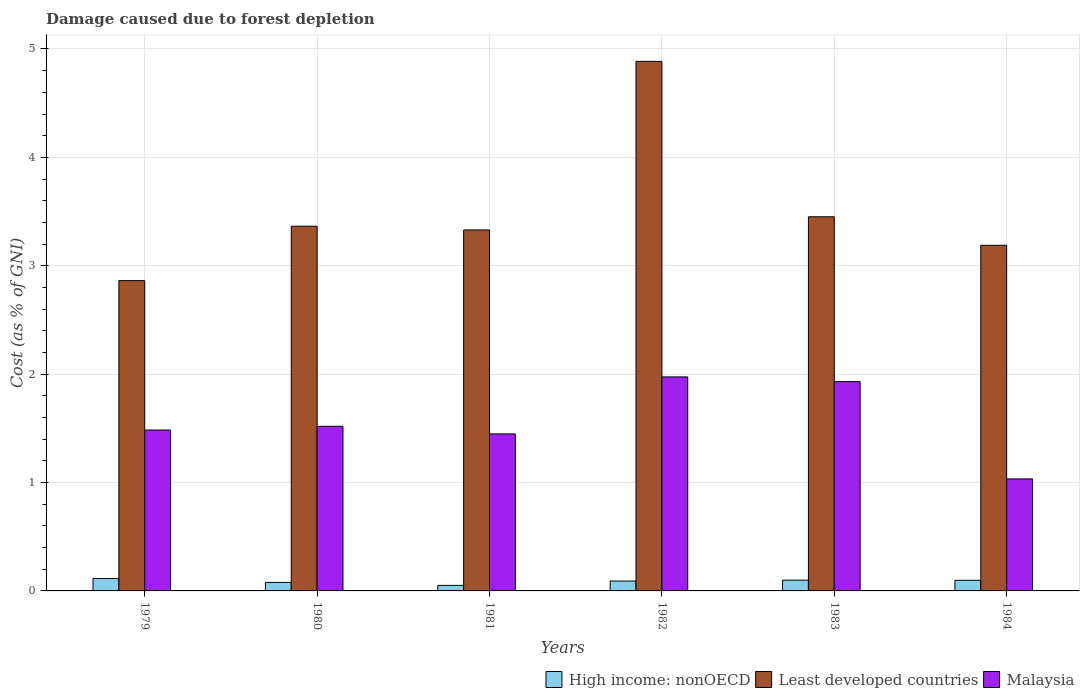How many different coloured bars are there?
Provide a short and direct response. 3. How many groups of bars are there?
Your response must be concise. 6. Are the number of bars on each tick of the X-axis equal?
Your answer should be very brief. Yes. What is the label of the 3rd group of bars from the left?
Offer a very short reply. 1981. What is the cost of damage caused due to forest depletion in Malaysia in 1982?
Keep it short and to the point. 1.97. Across all years, what is the maximum cost of damage caused due to forest depletion in Least developed countries?
Ensure brevity in your answer.  4.89. Across all years, what is the minimum cost of damage caused due to forest depletion in High income: nonOECD?
Provide a succinct answer. 0.05. In which year was the cost of damage caused due to forest depletion in High income: nonOECD maximum?
Your answer should be compact. 1979. In which year was the cost of damage caused due to forest depletion in Malaysia minimum?
Provide a succinct answer. 1984. What is the total cost of damage caused due to forest depletion in High income: nonOECD in the graph?
Your response must be concise. 0.53. What is the difference between the cost of damage caused due to forest depletion in High income: nonOECD in 1979 and that in 1980?
Ensure brevity in your answer.  0.04. What is the difference between the cost of damage caused due to forest depletion in High income: nonOECD in 1982 and the cost of damage caused due to forest depletion in Malaysia in 1979?
Make the answer very short. -1.39. What is the average cost of damage caused due to forest depletion in High income: nonOECD per year?
Your response must be concise. 0.09. In the year 1983, what is the difference between the cost of damage caused due to forest depletion in High income: nonOECD and cost of damage caused due to forest depletion in Least developed countries?
Your answer should be compact. -3.35. What is the ratio of the cost of damage caused due to forest depletion in High income: nonOECD in 1981 to that in 1983?
Give a very brief answer. 0.51. Is the cost of damage caused due to forest depletion in Malaysia in 1979 less than that in 1984?
Your answer should be compact. No. What is the difference between the highest and the second highest cost of damage caused due to forest depletion in High income: nonOECD?
Ensure brevity in your answer.  0.02. What is the difference between the highest and the lowest cost of damage caused due to forest depletion in High income: nonOECD?
Your response must be concise. 0.06. Is the sum of the cost of damage caused due to forest depletion in Least developed countries in 1979 and 1982 greater than the maximum cost of damage caused due to forest depletion in Malaysia across all years?
Your response must be concise. Yes. What does the 3rd bar from the left in 1984 represents?
Offer a very short reply. Malaysia. What does the 1st bar from the right in 1984 represents?
Provide a short and direct response. Malaysia. How many bars are there?
Offer a terse response. 18. How many years are there in the graph?
Provide a short and direct response. 6. Does the graph contain any zero values?
Ensure brevity in your answer.  No. Does the graph contain grids?
Offer a very short reply. Yes. How many legend labels are there?
Provide a short and direct response. 3. How are the legend labels stacked?
Your response must be concise. Horizontal. What is the title of the graph?
Your answer should be compact. Damage caused due to forest depletion. Does "Central Europe" appear as one of the legend labels in the graph?
Provide a short and direct response. No. What is the label or title of the X-axis?
Your answer should be compact. Years. What is the label or title of the Y-axis?
Provide a succinct answer. Cost (as % of GNI). What is the Cost (as % of GNI) of High income: nonOECD in 1979?
Offer a very short reply. 0.11. What is the Cost (as % of GNI) in Least developed countries in 1979?
Provide a succinct answer. 2.86. What is the Cost (as % of GNI) of Malaysia in 1979?
Offer a very short reply. 1.48. What is the Cost (as % of GNI) in High income: nonOECD in 1980?
Give a very brief answer. 0.08. What is the Cost (as % of GNI) in Least developed countries in 1980?
Offer a very short reply. 3.36. What is the Cost (as % of GNI) of Malaysia in 1980?
Provide a short and direct response. 1.52. What is the Cost (as % of GNI) of High income: nonOECD in 1981?
Your answer should be compact. 0.05. What is the Cost (as % of GNI) of Least developed countries in 1981?
Keep it short and to the point. 3.33. What is the Cost (as % of GNI) in Malaysia in 1981?
Provide a short and direct response. 1.45. What is the Cost (as % of GNI) in High income: nonOECD in 1982?
Your answer should be compact. 0.09. What is the Cost (as % of GNI) in Least developed countries in 1982?
Offer a terse response. 4.89. What is the Cost (as % of GNI) of Malaysia in 1982?
Keep it short and to the point. 1.97. What is the Cost (as % of GNI) in High income: nonOECD in 1983?
Your answer should be very brief. 0.1. What is the Cost (as % of GNI) of Least developed countries in 1983?
Offer a terse response. 3.45. What is the Cost (as % of GNI) in Malaysia in 1983?
Keep it short and to the point. 1.93. What is the Cost (as % of GNI) in High income: nonOECD in 1984?
Provide a short and direct response. 0.1. What is the Cost (as % of GNI) in Least developed countries in 1984?
Ensure brevity in your answer.  3.19. What is the Cost (as % of GNI) of Malaysia in 1984?
Ensure brevity in your answer.  1.03. Across all years, what is the maximum Cost (as % of GNI) of High income: nonOECD?
Provide a succinct answer. 0.11. Across all years, what is the maximum Cost (as % of GNI) of Least developed countries?
Offer a terse response. 4.89. Across all years, what is the maximum Cost (as % of GNI) of Malaysia?
Provide a short and direct response. 1.97. Across all years, what is the minimum Cost (as % of GNI) in High income: nonOECD?
Provide a short and direct response. 0.05. Across all years, what is the minimum Cost (as % of GNI) in Least developed countries?
Keep it short and to the point. 2.86. Across all years, what is the minimum Cost (as % of GNI) in Malaysia?
Make the answer very short. 1.03. What is the total Cost (as % of GNI) of High income: nonOECD in the graph?
Provide a succinct answer. 0.53. What is the total Cost (as % of GNI) of Least developed countries in the graph?
Offer a terse response. 21.09. What is the total Cost (as % of GNI) in Malaysia in the graph?
Offer a terse response. 9.39. What is the difference between the Cost (as % of GNI) of High income: nonOECD in 1979 and that in 1980?
Give a very brief answer. 0.04. What is the difference between the Cost (as % of GNI) in Least developed countries in 1979 and that in 1980?
Make the answer very short. -0.5. What is the difference between the Cost (as % of GNI) in Malaysia in 1979 and that in 1980?
Offer a terse response. -0.03. What is the difference between the Cost (as % of GNI) in High income: nonOECD in 1979 and that in 1981?
Make the answer very short. 0.06. What is the difference between the Cost (as % of GNI) of Least developed countries in 1979 and that in 1981?
Offer a very short reply. -0.47. What is the difference between the Cost (as % of GNI) in Malaysia in 1979 and that in 1981?
Give a very brief answer. 0.04. What is the difference between the Cost (as % of GNI) in High income: nonOECD in 1979 and that in 1982?
Provide a succinct answer. 0.02. What is the difference between the Cost (as % of GNI) in Least developed countries in 1979 and that in 1982?
Offer a terse response. -2.02. What is the difference between the Cost (as % of GNI) of Malaysia in 1979 and that in 1982?
Keep it short and to the point. -0.49. What is the difference between the Cost (as % of GNI) of High income: nonOECD in 1979 and that in 1983?
Give a very brief answer. 0.02. What is the difference between the Cost (as % of GNI) of Least developed countries in 1979 and that in 1983?
Give a very brief answer. -0.59. What is the difference between the Cost (as % of GNI) of Malaysia in 1979 and that in 1983?
Your answer should be very brief. -0.45. What is the difference between the Cost (as % of GNI) in High income: nonOECD in 1979 and that in 1984?
Make the answer very short. 0.02. What is the difference between the Cost (as % of GNI) in Least developed countries in 1979 and that in 1984?
Offer a very short reply. -0.33. What is the difference between the Cost (as % of GNI) of Malaysia in 1979 and that in 1984?
Ensure brevity in your answer.  0.45. What is the difference between the Cost (as % of GNI) in High income: nonOECD in 1980 and that in 1981?
Provide a succinct answer. 0.03. What is the difference between the Cost (as % of GNI) of Least developed countries in 1980 and that in 1981?
Provide a short and direct response. 0.03. What is the difference between the Cost (as % of GNI) of Malaysia in 1980 and that in 1981?
Make the answer very short. 0.07. What is the difference between the Cost (as % of GNI) of High income: nonOECD in 1980 and that in 1982?
Offer a terse response. -0.01. What is the difference between the Cost (as % of GNI) of Least developed countries in 1980 and that in 1982?
Provide a short and direct response. -1.52. What is the difference between the Cost (as % of GNI) of Malaysia in 1980 and that in 1982?
Ensure brevity in your answer.  -0.46. What is the difference between the Cost (as % of GNI) in High income: nonOECD in 1980 and that in 1983?
Make the answer very short. -0.02. What is the difference between the Cost (as % of GNI) in Least developed countries in 1980 and that in 1983?
Give a very brief answer. -0.09. What is the difference between the Cost (as % of GNI) of Malaysia in 1980 and that in 1983?
Your answer should be very brief. -0.41. What is the difference between the Cost (as % of GNI) in High income: nonOECD in 1980 and that in 1984?
Your answer should be compact. -0.02. What is the difference between the Cost (as % of GNI) of Least developed countries in 1980 and that in 1984?
Your response must be concise. 0.18. What is the difference between the Cost (as % of GNI) in Malaysia in 1980 and that in 1984?
Your answer should be very brief. 0.49. What is the difference between the Cost (as % of GNI) of High income: nonOECD in 1981 and that in 1982?
Offer a very short reply. -0.04. What is the difference between the Cost (as % of GNI) of Least developed countries in 1981 and that in 1982?
Provide a succinct answer. -1.56. What is the difference between the Cost (as % of GNI) of Malaysia in 1981 and that in 1982?
Provide a short and direct response. -0.53. What is the difference between the Cost (as % of GNI) of High income: nonOECD in 1981 and that in 1983?
Make the answer very short. -0.05. What is the difference between the Cost (as % of GNI) in Least developed countries in 1981 and that in 1983?
Offer a very short reply. -0.12. What is the difference between the Cost (as % of GNI) in Malaysia in 1981 and that in 1983?
Provide a succinct answer. -0.48. What is the difference between the Cost (as % of GNI) in High income: nonOECD in 1981 and that in 1984?
Make the answer very short. -0.05. What is the difference between the Cost (as % of GNI) in Least developed countries in 1981 and that in 1984?
Offer a very short reply. 0.14. What is the difference between the Cost (as % of GNI) of Malaysia in 1981 and that in 1984?
Make the answer very short. 0.42. What is the difference between the Cost (as % of GNI) of High income: nonOECD in 1982 and that in 1983?
Give a very brief answer. -0.01. What is the difference between the Cost (as % of GNI) in Least developed countries in 1982 and that in 1983?
Give a very brief answer. 1.43. What is the difference between the Cost (as % of GNI) in Malaysia in 1982 and that in 1983?
Provide a short and direct response. 0.04. What is the difference between the Cost (as % of GNI) in High income: nonOECD in 1982 and that in 1984?
Provide a succinct answer. -0.01. What is the difference between the Cost (as % of GNI) of Least developed countries in 1982 and that in 1984?
Give a very brief answer. 1.7. What is the difference between the Cost (as % of GNI) in Malaysia in 1982 and that in 1984?
Keep it short and to the point. 0.94. What is the difference between the Cost (as % of GNI) in High income: nonOECD in 1983 and that in 1984?
Offer a very short reply. 0. What is the difference between the Cost (as % of GNI) of Least developed countries in 1983 and that in 1984?
Your answer should be very brief. 0.26. What is the difference between the Cost (as % of GNI) of Malaysia in 1983 and that in 1984?
Provide a succinct answer. 0.9. What is the difference between the Cost (as % of GNI) of High income: nonOECD in 1979 and the Cost (as % of GNI) of Least developed countries in 1980?
Provide a short and direct response. -3.25. What is the difference between the Cost (as % of GNI) in High income: nonOECD in 1979 and the Cost (as % of GNI) in Malaysia in 1980?
Offer a terse response. -1.4. What is the difference between the Cost (as % of GNI) of Least developed countries in 1979 and the Cost (as % of GNI) of Malaysia in 1980?
Your response must be concise. 1.34. What is the difference between the Cost (as % of GNI) of High income: nonOECD in 1979 and the Cost (as % of GNI) of Least developed countries in 1981?
Your response must be concise. -3.22. What is the difference between the Cost (as % of GNI) in High income: nonOECD in 1979 and the Cost (as % of GNI) in Malaysia in 1981?
Give a very brief answer. -1.33. What is the difference between the Cost (as % of GNI) of Least developed countries in 1979 and the Cost (as % of GNI) of Malaysia in 1981?
Your answer should be very brief. 1.41. What is the difference between the Cost (as % of GNI) of High income: nonOECD in 1979 and the Cost (as % of GNI) of Least developed countries in 1982?
Offer a terse response. -4.77. What is the difference between the Cost (as % of GNI) of High income: nonOECD in 1979 and the Cost (as % of GNI) of Malaysia in 1982?
Make the answer very short. -1.86. What is the difference between the Cost (as % of GNI) in Least developed countries in 1979 and the Cost (as % of GNI) in Malaysia in 1982?
Your answer should be very brief. 0.89. What is the difference between the Cost (as % of GNI) in High income: nonOECD in 1979 and the Cost (as % of GNI) in Least developed countries in 1983?
Give a very brief answer. -3.34. What is the difference between the Cost (as % of GNI) in High income: nonOECD in 1979 and the Cost (as % of GNI) in Malaysia in 1983?
Keep it short and to the point. -1.82. What is the difference between the Cost (as % of GNI) in Least developed countries in 1979 and the Cost (as % of GNI) in Malaysia in 1983?
Offer a terse response. 0.93. What is the difference between the Cost (as % of GNI) of High income: nonOECD in 1979 and the Cost (as % of GNI) of Least developed countries in 1984?
Ensure brevity in your answer.  -3.07. What is the difference between the Cost (as % of GNI) in High income: nonOECD in 1979 and the Cost (as % of GNI) in Malaysia in 1984?
Your answer should be very brief. -0.92. What is the difference between the Cost (as % of GNI) in Least developed countries in 1979 and the Cost (as % of GNI) in Malaysia in 1984?
Make the answer very short. 1.83. What is the difference between the Cost (as % of GNI) in High income: nonOECD in 1980 and the Cost (as % of GNI) in Least developed countries in 1981?
Provide a short and direct response. -3.25. What is the difference between the Cost (as % of GNI) in High income: nonOECD in 1980 and the Cost (as % of GNI) in Malaysia in 1981?
Provide a succinct answer. -1.37. What is the difference between the Cost (as % of GNI) in Least developed countries in 1980 and the Cost (as % of GNI) in Malaysia in 1981?
Offer a terse response. 1.92. What is the difference between the Cost (as % of GNI) in High income: nonOECD in 1980 and the Cost (as % of GNI) in Least developed countries in 1982?
Your answer should be compact. -4.81. What is the difference between the Cost (as % of GNI) in High income: nonOECD in 1980 and the Cost (as % of GNI) in Malaysia in 1982?
Give a very brief answer. -1.9. What is the difference between the Cost (as % of GNI) of Least developed countries in 1980 and the Cost (as % of GNI) of Malaysia in 1982?
Keep it short and to the point. 1.39. What is the difference between the Cost (as % of GNI) in High income: nonOECD in 1980 and the Cost (as % of GNI) in Least developed countries in 1983?
Offer a terse response. -3.37. What is the difference between the Cost (as % of GNI) in High income: nonOECD in 1980 and the Cost (as % of GNI) in Malaysia in 1983?
Offer a very short reply. -1.85. What is the difference between the Cost (as % of GNI) of Least developed countries in 1980 and the Cost (as % of GNI) of Malaysia in 1983?
Ensure brevity in your answer.  1.43. What is the difference between the Cost (as % of GNI) in High income: nonOECD in 1980 and the Cost (as % of GNI) in Least developed countries in 1984?
Give a very brief answer. -3.11. What is the difference between the Cost (as % of GNI) in High income: nonOECD in 1980 and the Cost (as % of GNI) in Malaysia in 1984?
Provide a short and direct response. -0.95. What is the difference between the Cost (as % of GNI) of Least developed countries in 1980 and the Cost (as % of GNI) of Malaysia in 1984?
Provide a short and direct response. 2.33. What is the difference between the Cost (as % of GNI) of High income: nonOECD in 1981 and the Cost (as % of GNI) of Least developed countries in 1982?
Your answer should be very brief. -4.83. What is the difference between the Cost (as % of GNI) in High income: nonOECD in 1981 and the Cost (as % of GNI) in Malaysia in 1982?
Offer a terse response. -1.92. What is the difference between the Cost (as % of GNI) of Least developed countries in 1981 and the Cost (as % of GNI) of Malaysia in 1982?
Make the answer very short. 1.36. What is the difference between the Cost (as % of GNI) in High income: nonOECD in 1981 and the Cost (as % of GNI) in Least developed countries in 1983?
Keep it short and to the point. -3.4. What is the difference between the Cost (as % of GNI) of High income: nonOECD in 1981 and the Cost (as % of GNI) of Malaysia in 1983?
Offer a terse response. -1.88. What is the difference between the Cost (as % of GNI) of Least developed countries in 1981 and the Cost (as % of GNI) of Malaysia in 1983?
Provide a short and direct response. 1.4. What is the difference between the Cost (as % of GNI) in High income: nonOECD in 1981 and the Cost (as % of GNI) in Least developed countries in 1984?
Provide a succinct answer. -3.14. What is the difference between the Cost (as % of GNI) of High income: nonOECD in 1981 and the Cost (as % of GNI) of Malaysia in 1984?
Your answer should be compact. -0.98. What is the difference between the Cost (as % of GNI) in Least developed countries in 1981 and the Cost (as % of GNI) in Malaysia in 1984?
Your answer should be very brief. 2.3. What is the difference between the Cost (as % of GNI) of High income: nonOECD in 1982 and the Cost (as % of GNI) of Least developed countries in 1983?
Your answer should be very brief. -3.36. What is the difference between the Cost (as % of GNI) of High income: nonOECD in 1982 and the Cost (as % of GNI) of Malaysia in 1983?
Ensure brevity in your answer.  -1.84. What is the difference between the Cost (as % of GNI) in Least developed countries in 1982 and the Cost (as % of GNI) in Malaysia in 1983?
Your answer should be compact. 2.95. What is the difference between the Cost (as % of GNI) in High income: nonOECD in 1982 and the Cost (as % of GNI) in Least developed countries in 1984?
Make the answer very short. -3.1. What is the difference between the Cost (as % of GNI) in High income: nonOECD in 1982 and the Cost (as % of GNI) in Malaysia in 1984?
Keep it short and to the point. -0.94. What is the difference between the Cost (as % of GNI) in Least developed countries in 1982 and the Cost (as % of GNI) in Malaysia in 1984?
Your response must be concise. 3.85. What is the difference between the Cost (as % of GNI) in High income: nonOECD in 1983 and the Cost (as % of GNI) in Least developed countries in 1984?
Ensure brevity in your answer.  -3.09. What is the difference between the Cost (as % of GNI) in High income: nonOECD in 1983 and the Cost (as % of GNI) in Malaysia in 1984?
Provide a succinct answer. -0.93. What is the difference between the Cost (as % of GNI) in Least developed countries in 1983 and the Cost (as % of GNI) in Malaysia in 1984?
Your response must be concise. 2.42. What is the average Cost (as % of GNI) in High income: nonOECD per year?
Give a very brief answer. 0.09. What is the average Cost (as % of GNI) of Least developed countries per year?
Keep it short and to the point. 3.51. What is the average Cost (as % of GNI) of Malaysia per year?
Give a very brief answer. 1.57. In the year 1979, what is the difference between the Cost (as % of GNI) in High income: nonOECD and Cost (as % of GNI) in Least developed countries?
Your answer should be very brief. -2.75. In the year 1979, what is the difference between the Cost (as % of GNI) of High income: nonOECD and Cost (as % of GNI) of Malaysia?
Make the answer very short. -1.37. In the year 1979, what is the difference between the Cost (as % of GNI) of Least developed countries and Cost (as % of GNI) of Malaysia?
Provide a short and direct response. 1.38. In the year 1980, what is the difference between the Cost (as % of GNI) in High income: nonOECD and Cost (as % of GNI) in Least developed countries?
Your answer should be very brief. -3.29. In the year 1980, what is the difference between the Cost (as % of GNI) in High income: nonOECD and Cost (as % of GNI) in Malaysia?
Ensure brevity in your answer.  -1.44. In the year 1980, what is the difference between the Cost (as % of GNI) of Least developed countries and Cost (as % of GNI) of Malaysia?
Offer a very short reply. 1.85. In the year 1981, what is the difference between the Cost (as % of GNI) in High income: nonOECD and Cost (as % of GNI) in Least developed countries?
Your response must be concise. -3.28. In the year 1981, what is the difference between the Cost (as % of GNI) in High income: nonOECD and Cost (as % of GNI) in Malaysia?
Your answer should be compact. -1.4. In the year 1981, what is the difference between the Cost (as % of GNI) in Least developed countries and Cost (as % of GNI) in Malaysia?
Your response must be concise. 1.88. In the year 1982, what is the difference between the Cost (as % of GNI) in High income: nonOECD and Cost (as % of GNI) in Least developed countries?
Provide a short and direct response. -4.79. In the year 1982, what is the difference between the Cost (as % of GNI) in High income: nonOECD and Cost (as % of GNI) in Malaysia?
Provide a succinct answer. -1.88. In the year 1982, what is the difference between the Cost (as % of GNI) in Least developed countries and Cost (as % of GNI) in Malaysia?
Provide a succinct answer. 2.91. In the year 1983, what is the difference between the Cost (as % of GNI) in High income: nonOECD and Cost (as % of GNI) in Least developed countries?
Keep it short and to the point. -3.35. In the year 1983, what is the difference between the Cost (as % of GNI) in High income: nonOECD and Cost (as % of GNI) in Malaysia?
Offer a very short reply. -1.83. In the year 1983, what is the difference between the Cost (as % of GNI) of Least developed countries and Cost (as % of GNI) of Malaysia?
Your answer should be compact. 1.52. In the year 1984, what is the difference between the Cost (as % of GNI) in High income: nonOECD and Cost (as % of GNI) in Least developed countries?
Offer a very short reply. -3.09. In the year 1984, what is the difference between the Cost (as % of GNI) in High income: nonOECD and Cost (as % of GNI) in Malaysia?
Make the answer very short. -0.94. In the year 1984, what is the difference between the Cost (as % of GNI) of Least developed countries and Cost (as % of GNI) of Malaysia?
Provide a short and direct response. 2.16. What is the ratio of the Cost (as % of GNI) in High income: nonOECD in 1979 to that in 1980?
Make the answer very short. 1.47. What is the ratio of the Cost (as % of GNI) in Least developed countries in 1979 to that in 1980?
Your answer should be compact. 0.85. What is the ratio of the Cost (as % of GNI) of Malaysia in 1979 to that in 1980?
Give a very brief answer. 0.98. What is the ratio of the Cost (as % of GNI) in High income: nonOECD in 1979 to that in 1981?
Offer a terse response. 2.25. What is the ratio of the Cost (as % of GNI) in Least developed countries in 1979 to that in 1981?
Offer a terse response. 0.86. What is the ratio of the Cost (as % of GNI) of Malaysia in 1979 to that in 1981?
Provide a short and direct response. 1.02. What is the ratio of the Cost (as % of GNI) in High income: nonOECD in 1979 to that in 1982?
Provide a succinct answer. 1.26. What is the ratio of the Cost (as % of GNI) in Least developed countries in 1979 to that in 1982?
Offer a terse response. 0.59. What is the ratio of the Cost (as % of GNI) in Malaysia in 1979 to that in 1982?
Make the answer very short. 0.75. What is the ratio of the Cost (as % of GNI) of High income: nonOECD in 1979 to that in 1983?
Ensure brevity in your answer.  1.16. What is the ratio of the Cost (as % of GNI) in Least developed countries in 1979 to that in 1983?
Make the answer very short. 0.83. What is the ratio of the Cost (as % of GNI) in Malaysia in 1979 to that in 1983?
Offer a terse response. 0.77. What is the ratio of the Cost (as % of GNI) of High income: nonOECD in 1979 to that in 1984?
Provide a short and direct response. 1.17. What is the ratio of the Cost (as % of GNI) in Least developed countries in 1979 to that in 1984?
Offer a very short reply. 0.9. What is the ratio of the Cost (as % of GNI) of Malaysia in 1979 to that in 1984?
Offer a terse response. 1.44. What is the ratio of the Cost (as % of GNI) of High income: nonOECD in 1980 to that in 1981?
Your answer should be compact. 1.53. What is the ratio of the Cost (as % of GNI) of Least developed countries in 1980 to that in 1981?
Make the answer very short. 1.01. What is the ratio of the Cost (as % of GNI) of Malaysia in 1980 to that in 1981?
Give a very brief answer. 1.05. What is the ratio of the Cost (as % of GNI) in High income: nonOECD in 1980 to that in 1982?
Give a very brief answer. 0.86. What is the ratio of the Cost (as % of GNI) in Least developed countries in 1980 to that in 1982?
Keep it short and to the point. 0.69. What is the ratio of the Cost (as % of GNI) of Malaysia in 1980 to that in 1982?
Your response must be concise. 0.77. What is the ratio of the Cost (as % of GNI) in High income: nonOECD in 1980 to that in 1983?
Your answer should be very brief. 0.79. What is the ratio of the Cost (as % of GNI) of Least developed countries in 1980 to that in 1983?
Your answer should be very brief. 0.97. What is the ratio of the Cost (as % of GNI) in Malaysia in 1980 to that in 1983?
Your response must be concise. 0.79. What is the ratio of the Cost (as % of GNI) in High income: nonOECD in 1980 to that in 1984?
Your answer should be very brief. 0.8. What is the ratio of the Cost (as % of GNI) in Least developed countries in 1980 to that in 1984?
Provide a succinct answer. 1.06. What is the ratio of the Cost (as % of GNI) in Malaysia in 1980 to that in 1984?
Your response must be concise. 1.47. What is the ratio of the Cost (as % of GNI) of High income: nonOECD in 1981 to that in 1982?
Offer a very short reply. 0.56. What is the ratio of the Cost (as % of GNI) of Least developed countries in 1981 to that in 1982?
Keep it short and to the point. 0.68. What is the ratio of the Cost (as % of GNI) of Malaysia in 1981 to that in 1982?
Your answer should be compact. 0.73. What is the ratio of the Cost (as % of GNI) in High income: nonOECD in 1981 to that in 1983?
Your answer should be compact. 0.51. What is the ratio of the Cost (as % of GNI) in Least developed countries in 1981 to that in 1983?
Make the answer very short. 0.96. What is the ratio of the Cost (as % of GNI) in Malaysia in 1981 to that in 1983?
Your answer should be compact. 0.75. What is the ratio of the Cost (as % of GNI) of High income: nonOECD in 1981 to that in 1984?
Provide a succinct answer. 0.52. What is the ratio of the Cost (as % of GNI) of Least developed countries in 1981 to that in 1984?
Keep it short and to the point. 1.04. What is the ratio of the Cost (as % of GNI) of Malaysia in 1981 to that in 1984?
Provide a short and direct response. 1.4. What is the ratio of the Cost (as % of GNI) of High income: nonOECD in 1982 to that in 1983?
Provide a succinct answer. 0.92. What is the ratio of the Cost (as % of GNI) of Least developed countries in 1982 to that in 1983?
Give a very brief answer. 1.42. What is the ratio of the Cost (as % of GNI) of Malaysia in 1982 to that in 1983?
Offer a very short reply. 1.02. What is the ratio of the Cost (as % of GNI) in High income: nonOECD in 1982 to that in 1984?
Ensure brevity in your answer.  0.93. What is the ratio of the Cost (as % of GNI) in Least developed countries in 1982 to that in 1984?
Make the answer very short. 1.53. What is the ratio of the Cost (as % of GNI) of Malaysia in 1982 to that in 1984?
Keep it short and to the point. 1.91. What is the ratio of the Cost (as % of GNI) of High income: nonOECD in 1983 to that in 1984?
Provide a short and direct response. 1.01. What is the ratio of the Cost (as % of GNI) of Least developed countries in 1983 to that in 1984?
Make the answer very short. 1.08. What is the ratio of the Cost (as % of GNI) of Malaysia in 1983 to that in 1984?
Your response must be concise. 1.87. What is the difference between the highest and the second highest Cost (as % of GNI) in High income: nonOECD?
Keep it short and to the point. 0.02. What is the difference between the highest and the second highest Cost (as % of GNI) of Least developed countries?
Give a very brief answer. 1.43. What is the difference between the highest and the second highest Cost (as % of GNI) of Malaysia?
Your answer should be very brief. 0.04. What is the difference between the highest and the lowest Cost (as % of GNI) of High income: nonOECD?
Offer a terse response. 0.06. What is the difference between the highest and the lowest Cost (as % of GNI) in Least developed countries?
Offer a terse response. 2.02. What is the difference between the highest and the lowest Cost (as % of GNI) in Malaysia?
Provide a succinct answer. 0.94. 